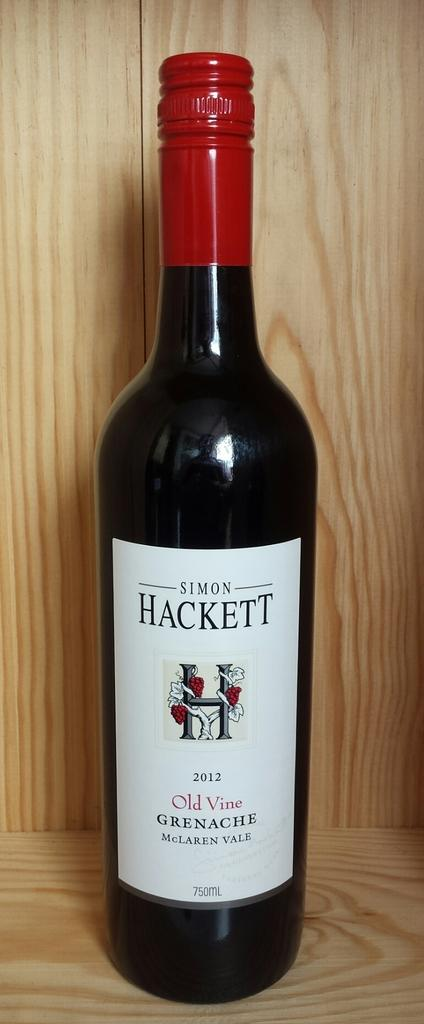<image>
Provide a brief description of the given image. A bottle of Simon Hackett Old Vine Grenache from 2011. 